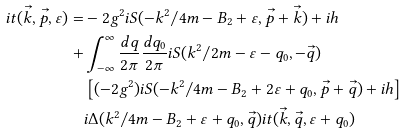Convert formula to latex. <formula><loc_0><loc_0><loc_500><loc_500>i t ( \vec { k } , \vec { p } , \varepsilon ) = & - 2 g ^ { 2 } i S ( - k ^ { 2 } / 4 m - B _ { 2 } + \varepsilon , \vec { p } + \vec { k } ) + i h \\ + & \int _ { - \infty } ^ { \infty } { \frac { d q } { 2 \pi } \frac { d q _ { 0 } } { 2 \pi } } i S ( k ^ { 2 } / 2 m - \varepsilon - q _ { 0 } , - \vec { q } ) \\ & \left [ ( - 2 g ^ { 2 } ) i S ( - k ^ { 2 } / 4 m - B _ { 2 } + 2 \varepsilon + q _ { 0 } , \vec { p } + \vec { q } ) + i h \right ] \\ & i \Delta ( k ^ { 2 } / 4 m - B _ { 2 } + \varepsilon + q _ { 0 } , \vec { q } ) i t ( \vec { k } , \vec { q } , \varepsilon + q _ { 0 } )</formula> 